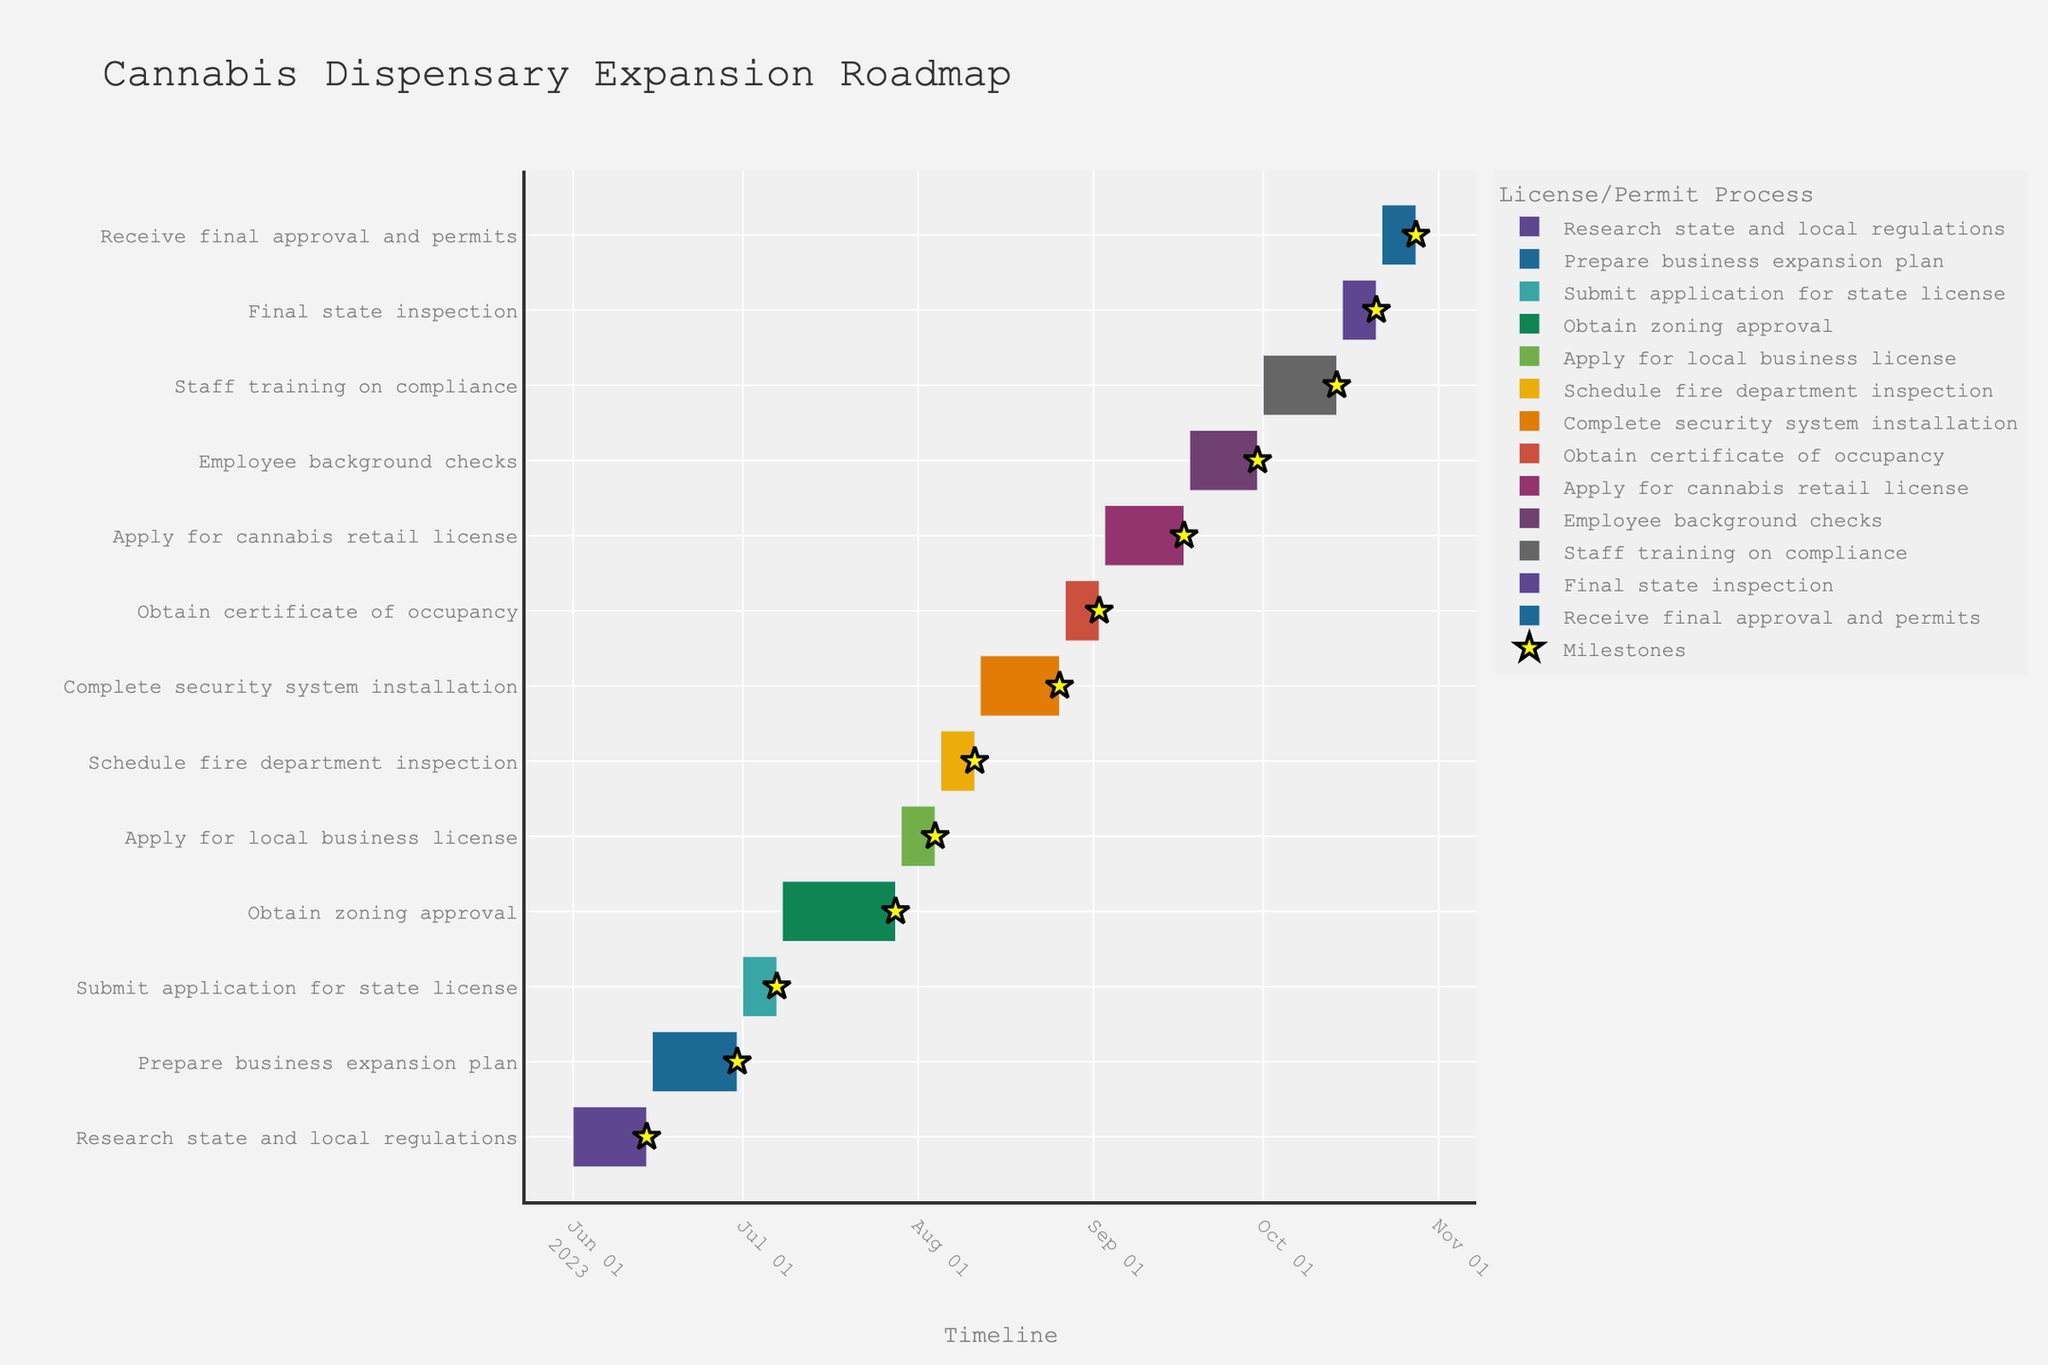What is the title of the Gantt chart? The title is typically located at the top of the chart. In this case, "Cannabis Dispensary Expansion Roadmap" is clearly displayed.
Answer: Cannabis Dispensary Expansion Roadmap What task starts immediately after "Prepare business expansion plan"? To find tasks' chronological order, follow the ending date of "Prepare business expansion plan" and find the next starting date. The ending date for "Prepare business expansion plan" is 2023-06-30, and the next task starts on 2023-07-01.
Answer: Submit application for state license How long is the duration of the "Complete security system installation" task? Check the listed durations next to each task in the data table and locate the "Complete security system installation" entry. It is marked to last 15 days.
Answer: 15 days Which tasks have a duration of 7 days? Multiple tasks may have the same duration. By checking each task, find those listed with 7 days: "Submit application for state license," "Apply for local business license," "Schedule fire department inspection," "Obtain certificate of occupancy," "Final state inspection," and "Receive final approval and permits."
Answer: Six tasks When does "Staff training on compliance" start and end? Look at the start and end dates for the "Staff training on compliance" task in the chart. It starts on 2023-10-01 and ends on 2023-10-14.
Answer: Starts on 2023-10-01 and ends on 2023-10-14 What is the difference in duration between "Research state and local regulations" and "Obtain zoning approval"? Find the durations of both tasks, then compute the difference. "Research state and local regulations" takes 14 days, "Obtain zoning approval" takes 21 days. The difference is calculated as 21 - 14 = 7 days.
Answer: 7 days Which task finishes the latest in the timeline? Check the ending date of all tasks in the data table. The latest task ends on 2023-10-28.
Answer: Receive final approval and permits How many tasks overlap with "Employee background checks"? "Employee background checks" occurs between 2023-09-18 and 2023-09-30. Count all other tasks that have any overlapping dates with this period.
Answer: Two tasks Which task has the shortest duration? By scanning through the listed durations, identify the minimum value. Several tasks share the shortest duration of 7 days.
Answer: Submit application for state license, Apply for local business license, Schedule fire department inspection, Obtain certificate of occupancy, Final state inspection, Receive final approval and permits What is the total duration from the start of "Research state and local regulations" to the end of "Receive final approval and permits"? Calculate the difference between the start date of the first task and the end date of the last task. Start date is 2023-06-01, end date is 2023-10-28. The total duration from 2023-06-01 to 2023-10-28 is 150 days.
Answer: 150 days 